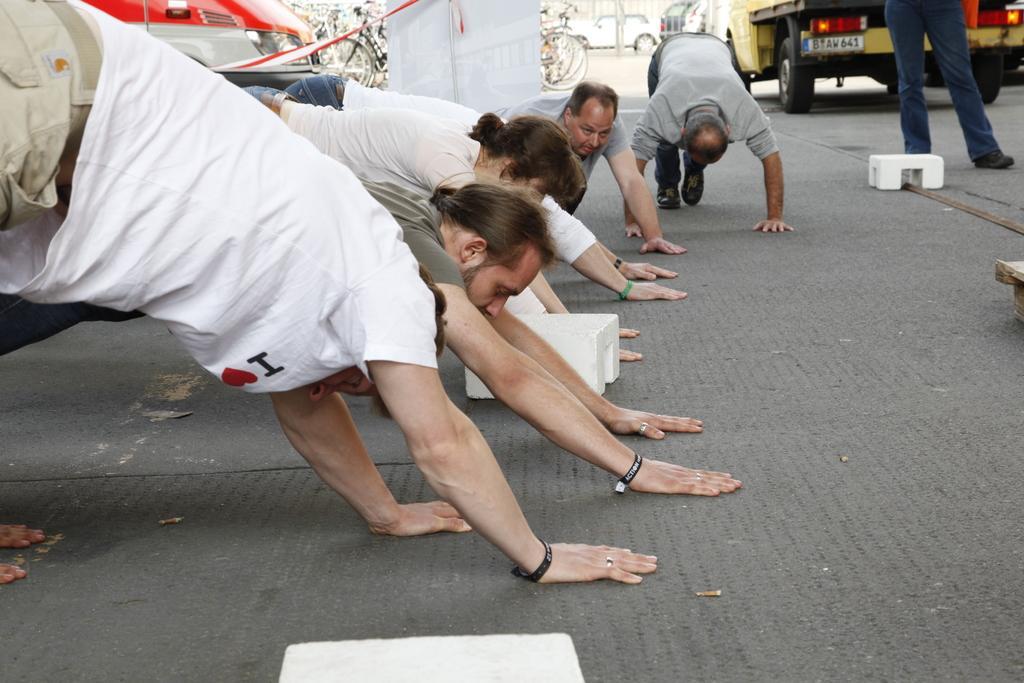Please provide a concise description of this image. In the picture I can see few persons placed their hands and legs on the ground and there are few other objects and vehicles in the background. 